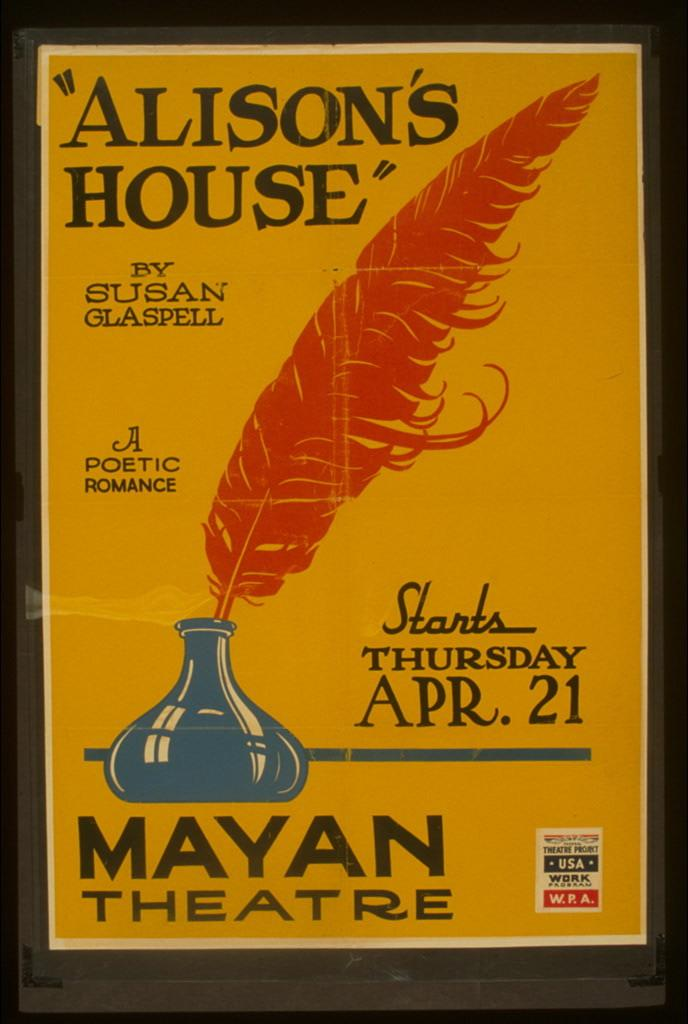<image>
Describe the image concisely. The Mayan Theatre is showing Alison's House on Apr. 21. 